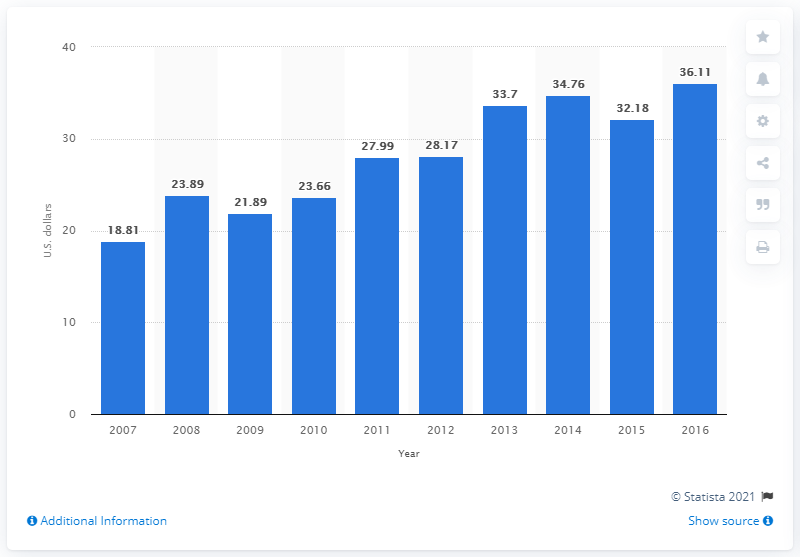Indicate a few pertinent items in this graphic. In 2014, the average American spent 34.76 on Valentine's Day gifts for their friends. 